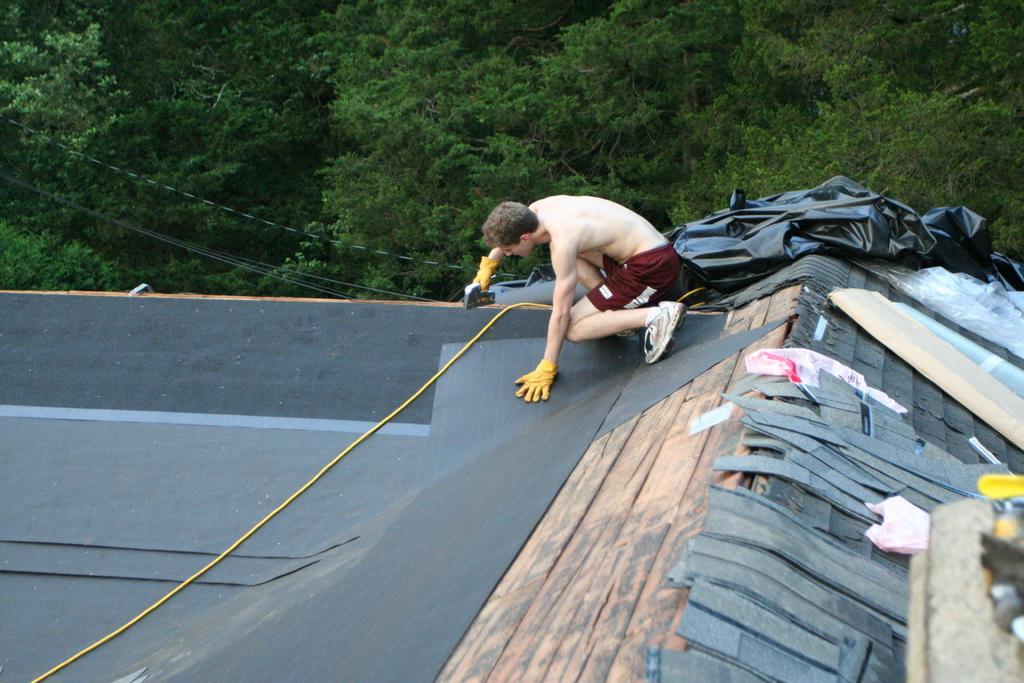Describe this image in one or two sentences. In this image there is a person sitting on the roof of a building and fitting something with help of drilling machine beside that there are so many trees. 